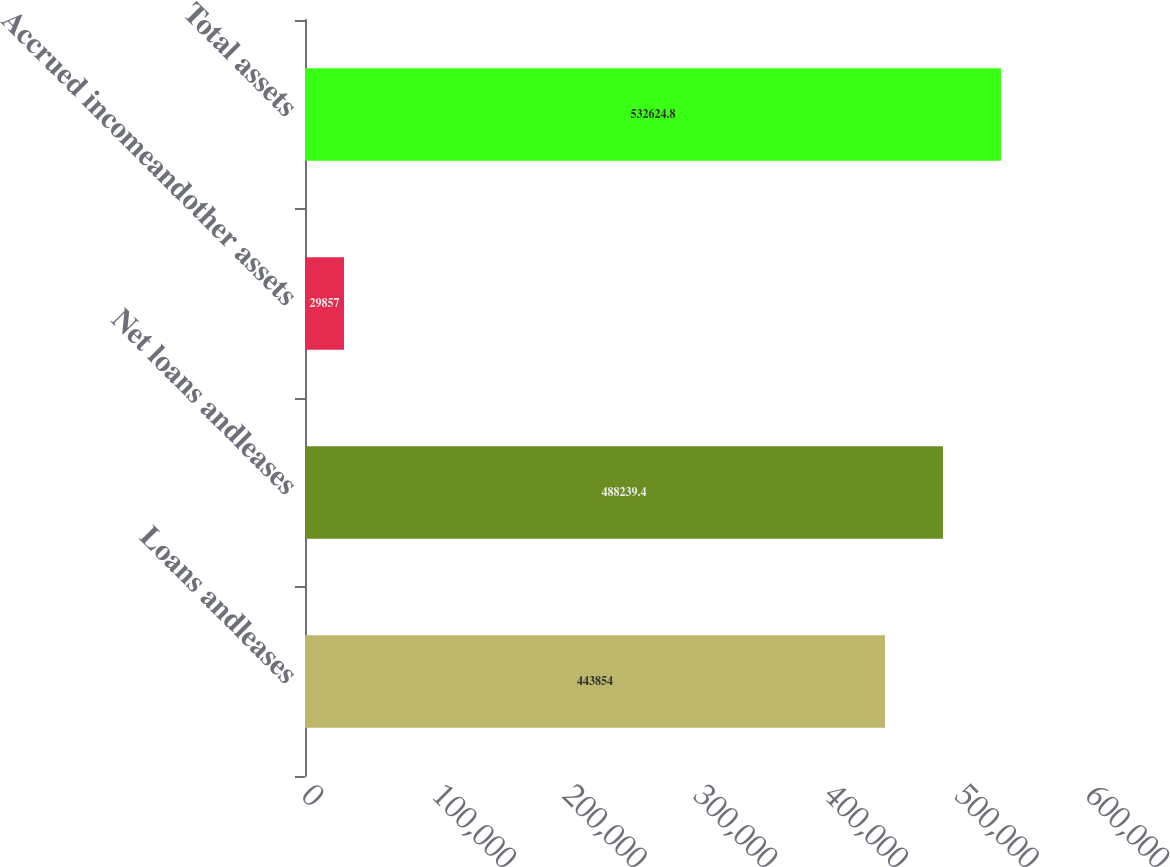<chart> <loc_0><loc_0><loc_500><loc_500><bar_chart><fcel>Loans andleases<fcel>Net loans andleases<fcel>Accrued incomeandother assets<fcel>Total assets<nl><fcel>443854<fcel>488239<fcel>29857<fcel>532625<nl></chart> 